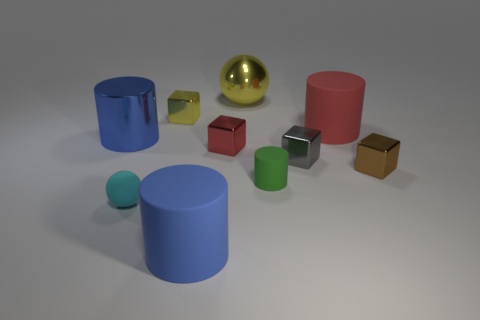Is the blue thing that is behind the small red shiny cube made of the same material as the large thing behind the yellow cube?
Offer a very short reply. Yes. What shape is the small thing that is the same color as the big ball?
Give a very brief answer. Cube. What number of purple things are either rubber things or rubber spheres?
Your response must be concise. 0. How big is the yellow ball?
Provide a succinct answer. Large. Is the number of big matte objects that are in front of the big red matte thing greater than the number of large purple metal balls?
Your response must be concise. Yes. What number of blue rubber cylinders are right of the big yellow object?
Keep it short and to the point. 0. Are there any cyan metal things of the same size as the red cube?
Provide a short and direct response. No. What color is the other matte thing that is the same shape as the big yellow thing?
Provide a succinct answer. Cyan. There is a cylinder in front of the tiny green object; is it the same size as the cylinder on the left side of the blue rubber cylinder?
Provide a succinct answer. Yes. Are there any large red rubber objects of the same shape as the gray metal thing?
Offer a terse response. No. 